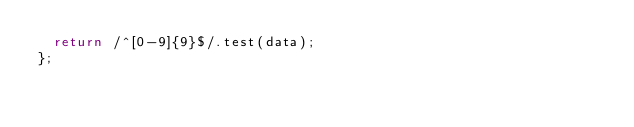Convert code to text. <code><loc_0><loc_0><loc_500><loc_500><_TypeScript_>  return /^[0-9]{9}$/.test(data);
};
</code> 